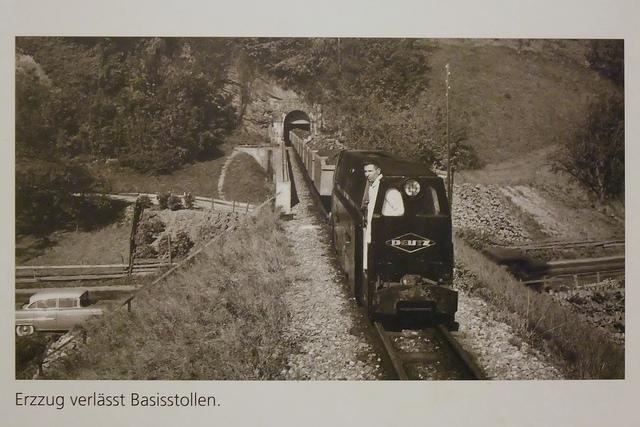How many rows of benches are there?
Give a very brief answer. 0. 